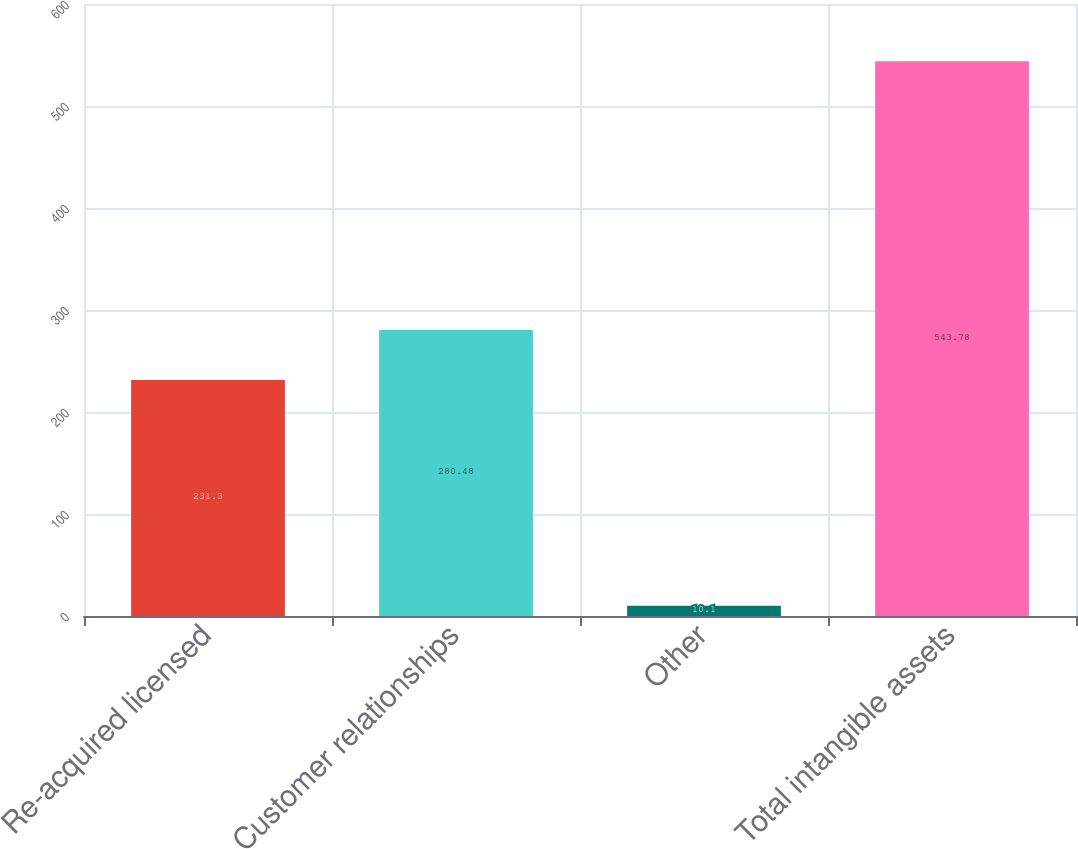Convert chart to OTSL. <chart><loc_0><loc_0><loc_500><loc_500><bar_chart><fcel>Re-acquired licensed<fcel>Customer relationships<fcel>Other<fcel>Total intangible assets<nl><fcel>231.3<fcel>280.48<fcel>10.1<fcel>543.78<nl></chart> 